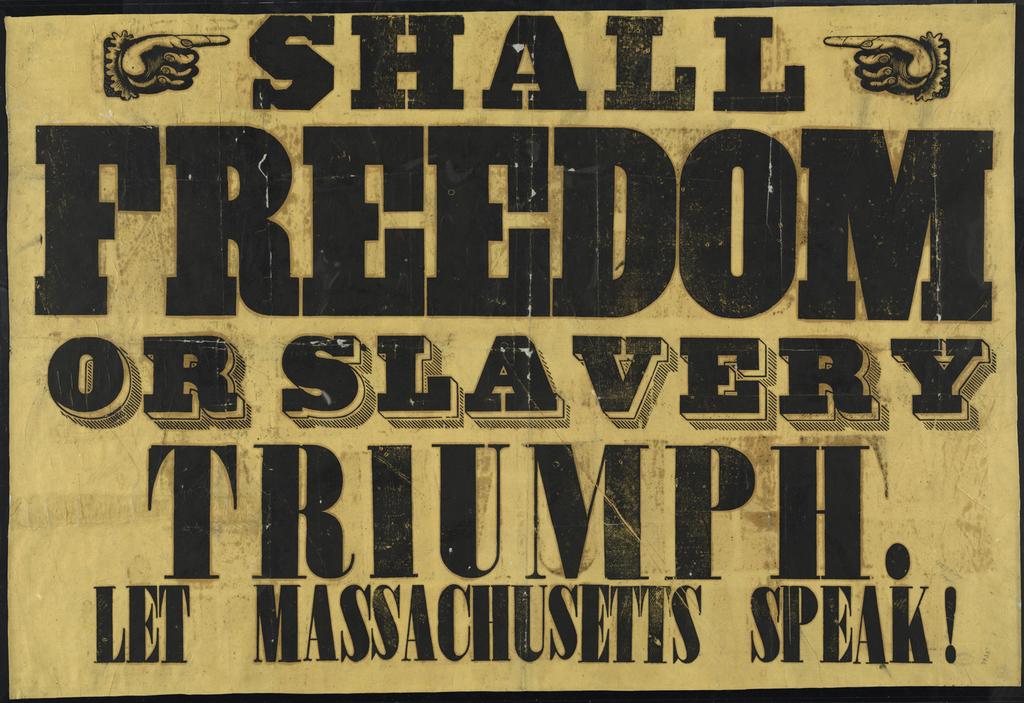What does the text say?
Offer a very short reply. Shall freedom or slavery triumph. let massachusetts speak!. 